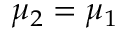Convert formula to latex. <formula><loc_0><loc_0><loc_500><loc_500>\mu _ { 2 } = \mu _ { 1 }</formula> 